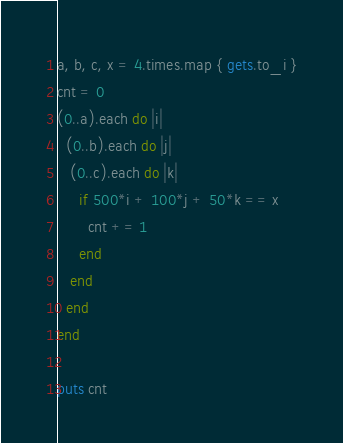Convert code to text. <code><loc_0><loc_0><loc_500><loc_500><_Ruby_>a, b, c, x = 4.times.map { gets.to_i }
cnt = 0
(0..a).each do |i|
  (0..b).each do |j|
   (0..c).each do |k|
     if 500*i + 100*j + 50*k == x
       cnt += 1
     end
   end
  end
end
 
puts cnt</code> 